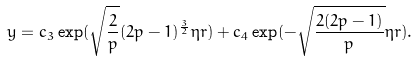Convert formula to latex. <formula><loc_0><loc_0><loc_500><loc_500>y = c _ { 3 } \exp ( \sqrt { \frac { 2 } { p } } ( 2 p - 1 ) ^ { \frac { 3 } { 2 } } \eta r ) + c _ { 4 } \exp ( - \sqrt { \frac { 2 ( 2 p - 1 ) } { p } } \eta r ) .</formula> 